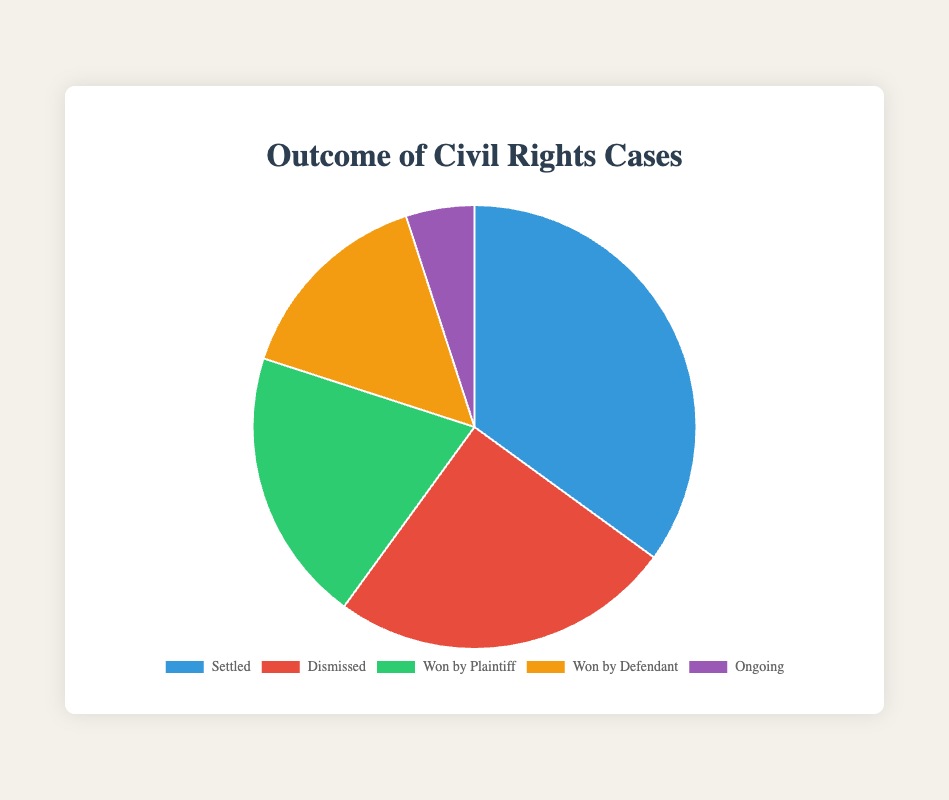Which outcome has the highest percentage? The pie chart shows that "Settled" has the largest slice, representing 35% of the outcomes, which is the highest percentage.
Answer: "Settled," 35% Which outcome has the lowest percentage? The pie chart shows that the "Ongoing" slice is the smallest, representing 5% of the outcomes, which is the lowest percentage.
Answer: "Ongoing," 5% How much more common is a case being settled compared to it being ongoing? "Settled" cases account for 35%, while "Ongoing" cases account for 5%. The difference is 35% - 5% = 30%.
Answer: 30% What's the combined percentage of cases that were either dismissed or won by the defendant? The chart shows that "Dismissed" is 25% and "Won by Defendant" is 15%. Summing these gives 25% + 15% = 40%.
Answer: 40% If a case is not ongoing, what is the probability that it was dismissed? Excluding "Ongoing," the percentages are "Settled" (35%), "Dismissed" (25%), "Won by Plaintiff" (20%), and "Won by Defendant" (15%). Their sum is 35% + 25% + 20% + 15% = 95%. The ratio of "Dismissed" to these cases is 25% / 95% ≈ 26.32%.
Answer: ≈ 26.32% Among the cases that were not settled, what percentage was won by the plaintiff? Excluding "Settled" (35%), the remaining percentages are "Dismissed" (25%), "Won by Plaintiff" (20%), "Won by Defendant" (15%), and "Ongoing" (5%). Their sum is 65%. The ratio of "Won by Plaintiff" to these cases is 20% / 65% ≈ 30.77%.
Answer: ≈ 30.77% What is the ratio between cases won by the plaintiff and those dismissed? The chart shows that "Won by Plaintiff" is 20% and "Dismissed" is 25%. The ratio is 20% / 25% = 0.8.
Answer: 0.8 Is the number of cases dismissed greater than the combined number of cases won by the plaintiff and ongoing? "Dismissed" is 25%, "Won by Plaintiff" is 20%, and "Ongoing" is 5%. The combined percentage of the latter two is 20% + 5% = 25%, which is equal to the "Dismissed" percentage.
Answer: No, they are equal If we combine the cases that are either settled or won by the plaintiff, what percentage do we get? The chart shows "Settled" is 35% and "Won by Plaintiff" is 20%. Their combined percentage is 35% + 20% = 55%.
Answer: 55% Which two outcomes combined represent exactly 40% of the cases? "Dismissed" is 25%, and "Won by Defendant" is 15%. Their combined percentage is 25% + 15% = 40%.
Answer: "Dismissed" and "Won by Defendant" 